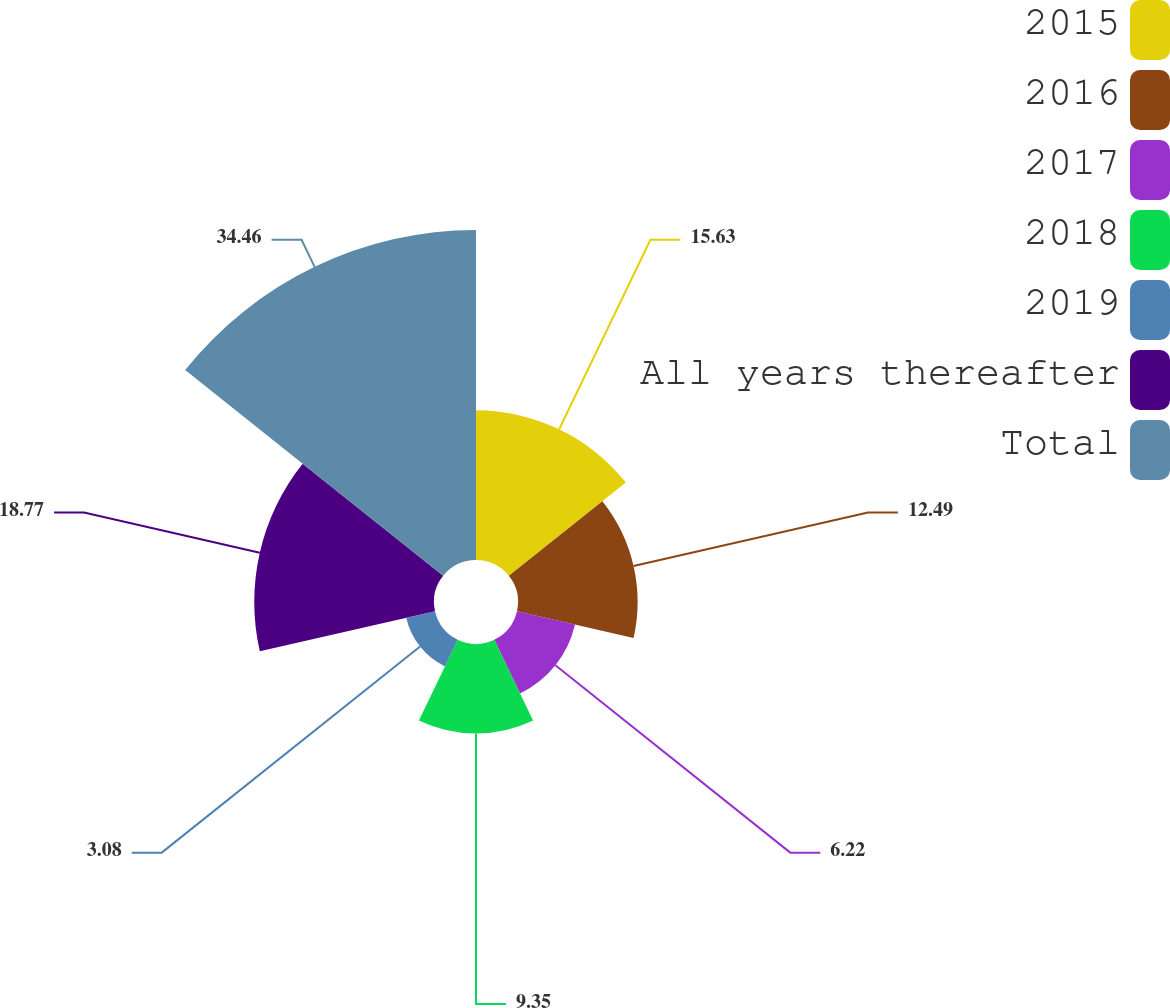<chart> <loc_0><loc_0><loc_500><loc_500><pie_chart><fcel>2015<fcel>2016<fcel>2017<fcel>2018<fcel>2019<fcel>All years thereafter<fcel>Total<nl><fcel>15.63%<fcel>12.49%<fcel>6.22%<fcel>9.35%<fcel>3.08%<fcel>18.77%<fcel>34.46%<nl></chart> 